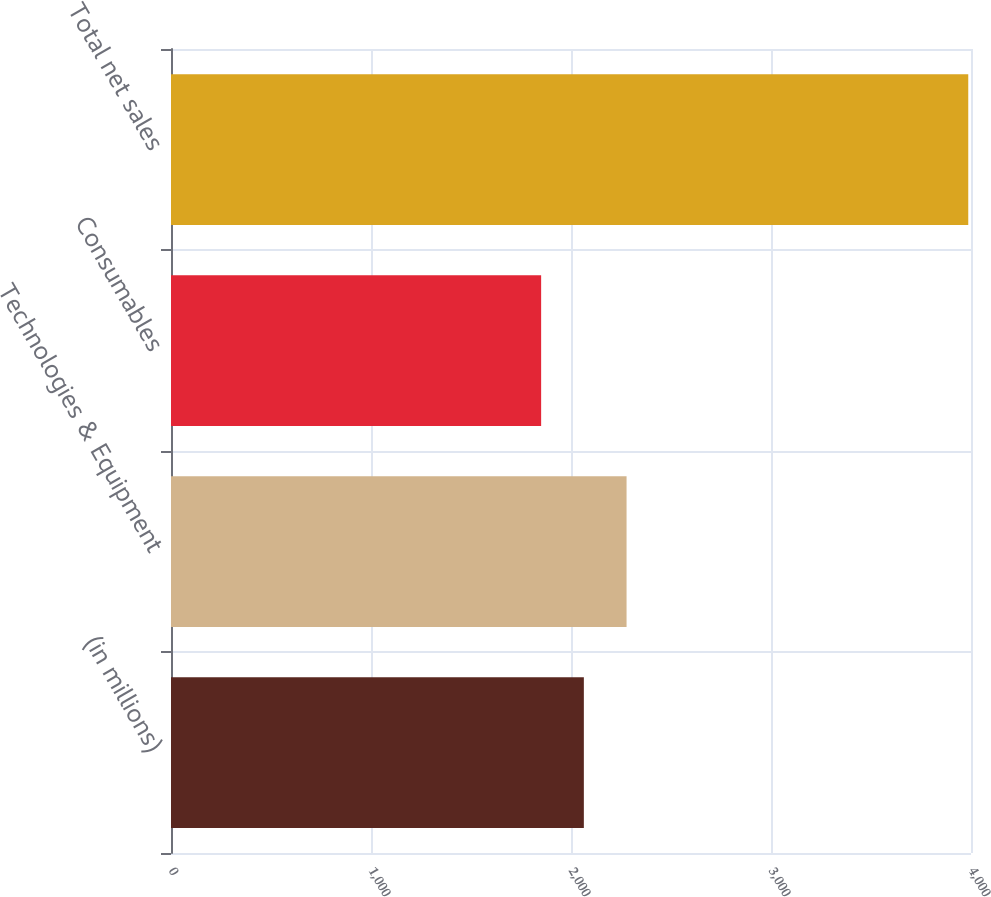Convert chart to OTSL. <chart><loc_0><loc_0><loc_500><loc_500><bar_chart><fcel>(in millions)<fcel>Technologies & Equipment<fcel>Consumables<fcel>Total net sales<nl><fcel>2064.26<fcel>2277.82<fcel>1850.7<fcel>3986.3<nl></chart> 